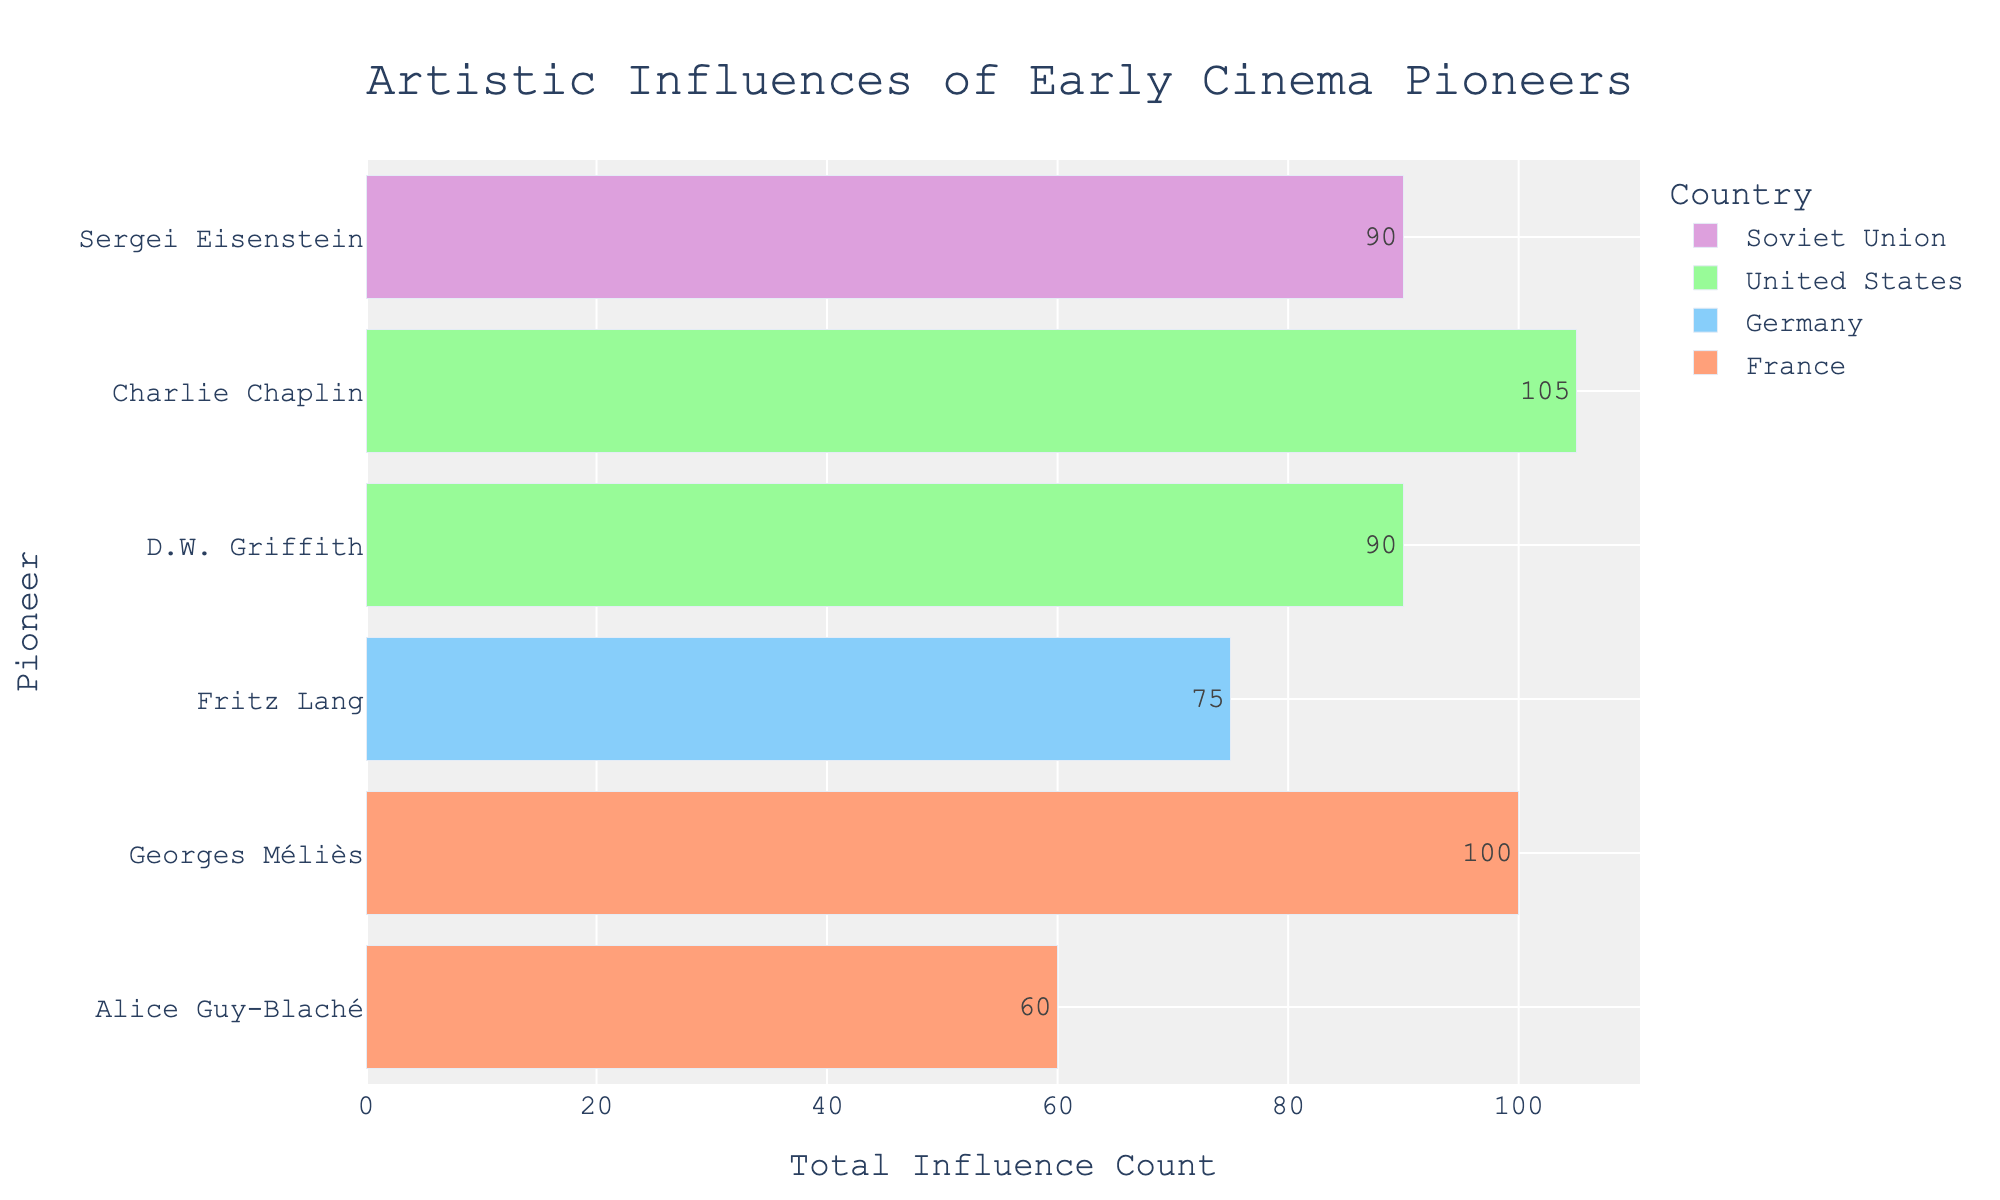Which two pioneers have the highest total influence counts, and which countries do they belong to? By observing the length of the bars and checking the hover information, Georges Méliès from France and Charlie Chaplin from the United States have the highest total influence counts.
Answer: Georges Méliès (France), Charlie Chaplin (United States) Compare the total influence counts of D.W. Griffith and Sergei Eisenstein. Who has the higher count? By examining the lengths of their respective bars, Sergei Eisenstein has a longer bar compared to D.W. Griffith, indicating a higher total influence count.
Answer: Sergei Eisenstein Which pioneer has the lowest total influence count, and what is the value? By looking at the shortest bar in the plot, Alice Guy-Blaché from France has the lowest total influence count.
Answer: Alice Guy-Blaché What is the combined total influence count of Fritz Lang's influences? By referring to the length of Fritz Lang's bar and hover information, the combined total influence count is determined from the data. Add the influence counts: Expressionist Art Movement (30), Theater (20), Mythology (25).
Answer: 75 How does the influence count for “Science Fiction” for Georges Méliès compare to “Slapstick Comedy” for Charlie Chaplin? “Science Fiction” for Georges Méliès has an influence count of 25, while “Slapstick Comedy” for Charlie Chaplin has a higher count of 35 as seen from the data table.
Answer: Slapstick Comedy has a higher count by 10 Which country's pioneers have the widest range of total influence counts, and what is that range? France has the widest range of total influence counts. By comparing the highest count (Georges Méliès) and the lowest count (Alice Guy-Blaché), the range is the difference between 100 and 60.
Answer: France, range is 40 Which country is associated with more pioneers in the plot? By counting the pioneers for each country indicated in the plot, France (Georges Méliès, Alice Guy-Blaché), the United States (D.W. Griffith, Charlie Chaplin), Germany (Fritz Lang), and the Soviet Union (Sergei Eisenstein) are considered.
Answer: The United States and France (both have 2 pioneers) What is the average influence count for Alice Guy-Blaché's influences? Sum Alice Guy-Blaché's influences (Theater 20, Literature 24, Painting 16) to get a total of 60, then divide by the number of influences (3).
Answer: 20 Which pioneer has the most diverse set of influences (i.e., the highest number of different influences)? From the data table, Georges Méliès has the most diverse set of influences: Theater, Magic Shows, Literature, Painting, Science Fiction.
Answer: Georges Méliès Comparing the counts of “Theater” as an influence among the pioneers, which two pioneers have the highest counts related to “Theater”? For “Theater” influence: Georges Méliès (20), D.W. Griffith (25), Fritz Lang (20), Alice Guy-Blaché (20), Sergei Eisenstein (20). D.W. Griffith has the highest count, and the others are tied.
Answer: D.W. Griffith, Others tied 